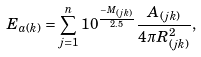<formula> <loc_0><loc_0><loc_500><loc_500>E _ { a ( k ) } = \sum _ { j = 1 } ^ { n } 1 0 ^ { \frac { - M _ { ( j k ) } } { 2 . 5 } } \frac { A _ { ( j k ) } } { 4 \pi R _ { ( j k ) } ^ { 2 } } ,</formula> 